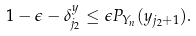Convert formula to latex. <formula><loc_0><loc_0><loc_500><loc_500>1 - \epsilon - \delta _ { j _ { 2 } } ^ { y } \leq \epsilon P _ { Y _ { n } } ( y _ { j _ { 2 } + 1 } ) .</formula> 